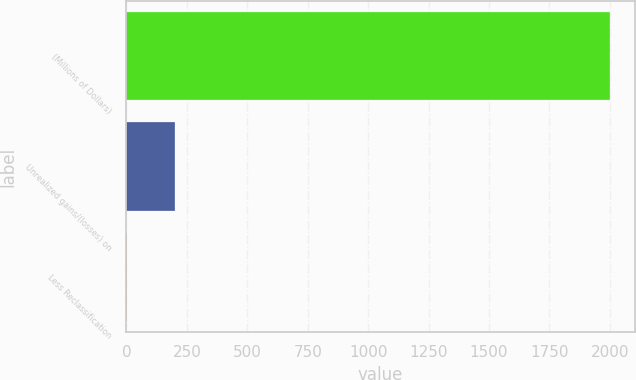Convert chart to OTSL. <chart><loc_0><loc_0><loc_500><loc_500><bar_chart><fcel>(Millions of Dollars)<fcel>Unrealized gains/(losses) on<fcel>Less Reclassification<nl><fcel>2002<fcel>201.1<fcel>1<nl></chart> 